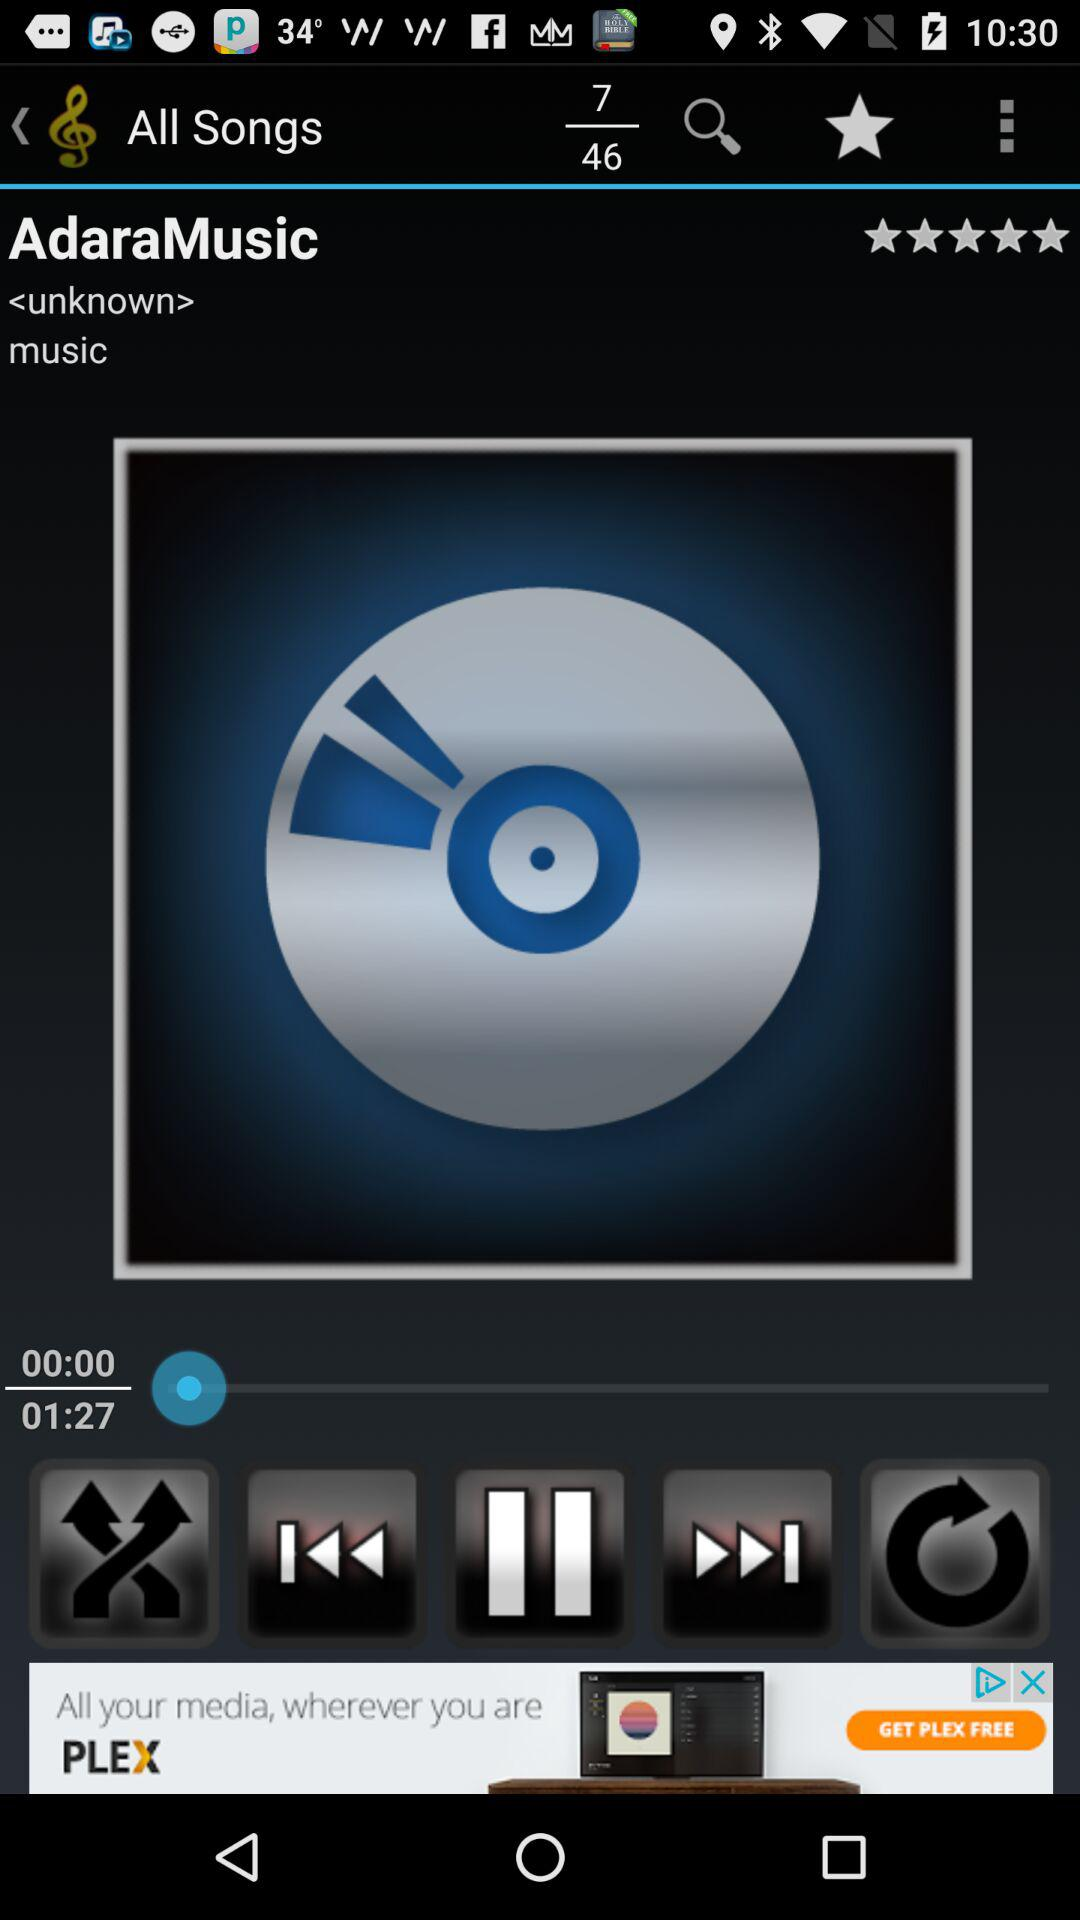Which song number is playing right now? The song number playing right now is 7. 